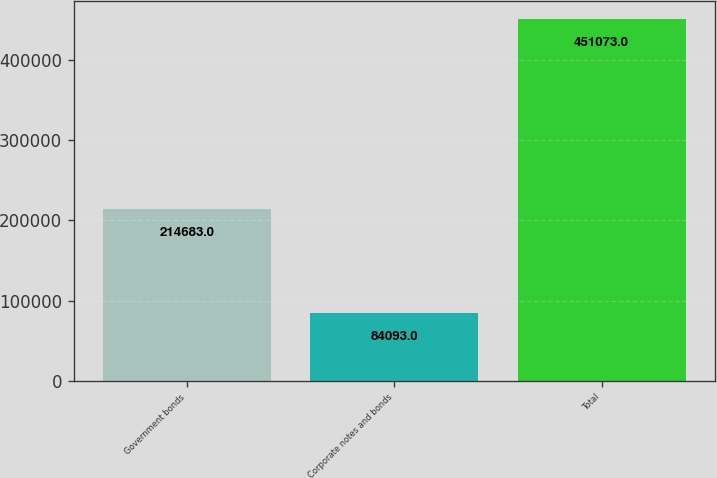Convert chart. <chart><loc_0><loc_0><loc_500><loc_500><bar_chart><fcel>Government bonds<fcel>Corporate notes and bonds<fcel>Total<nl><fcel>214683<fcel>84093<fcel>451073<nl></chart> 